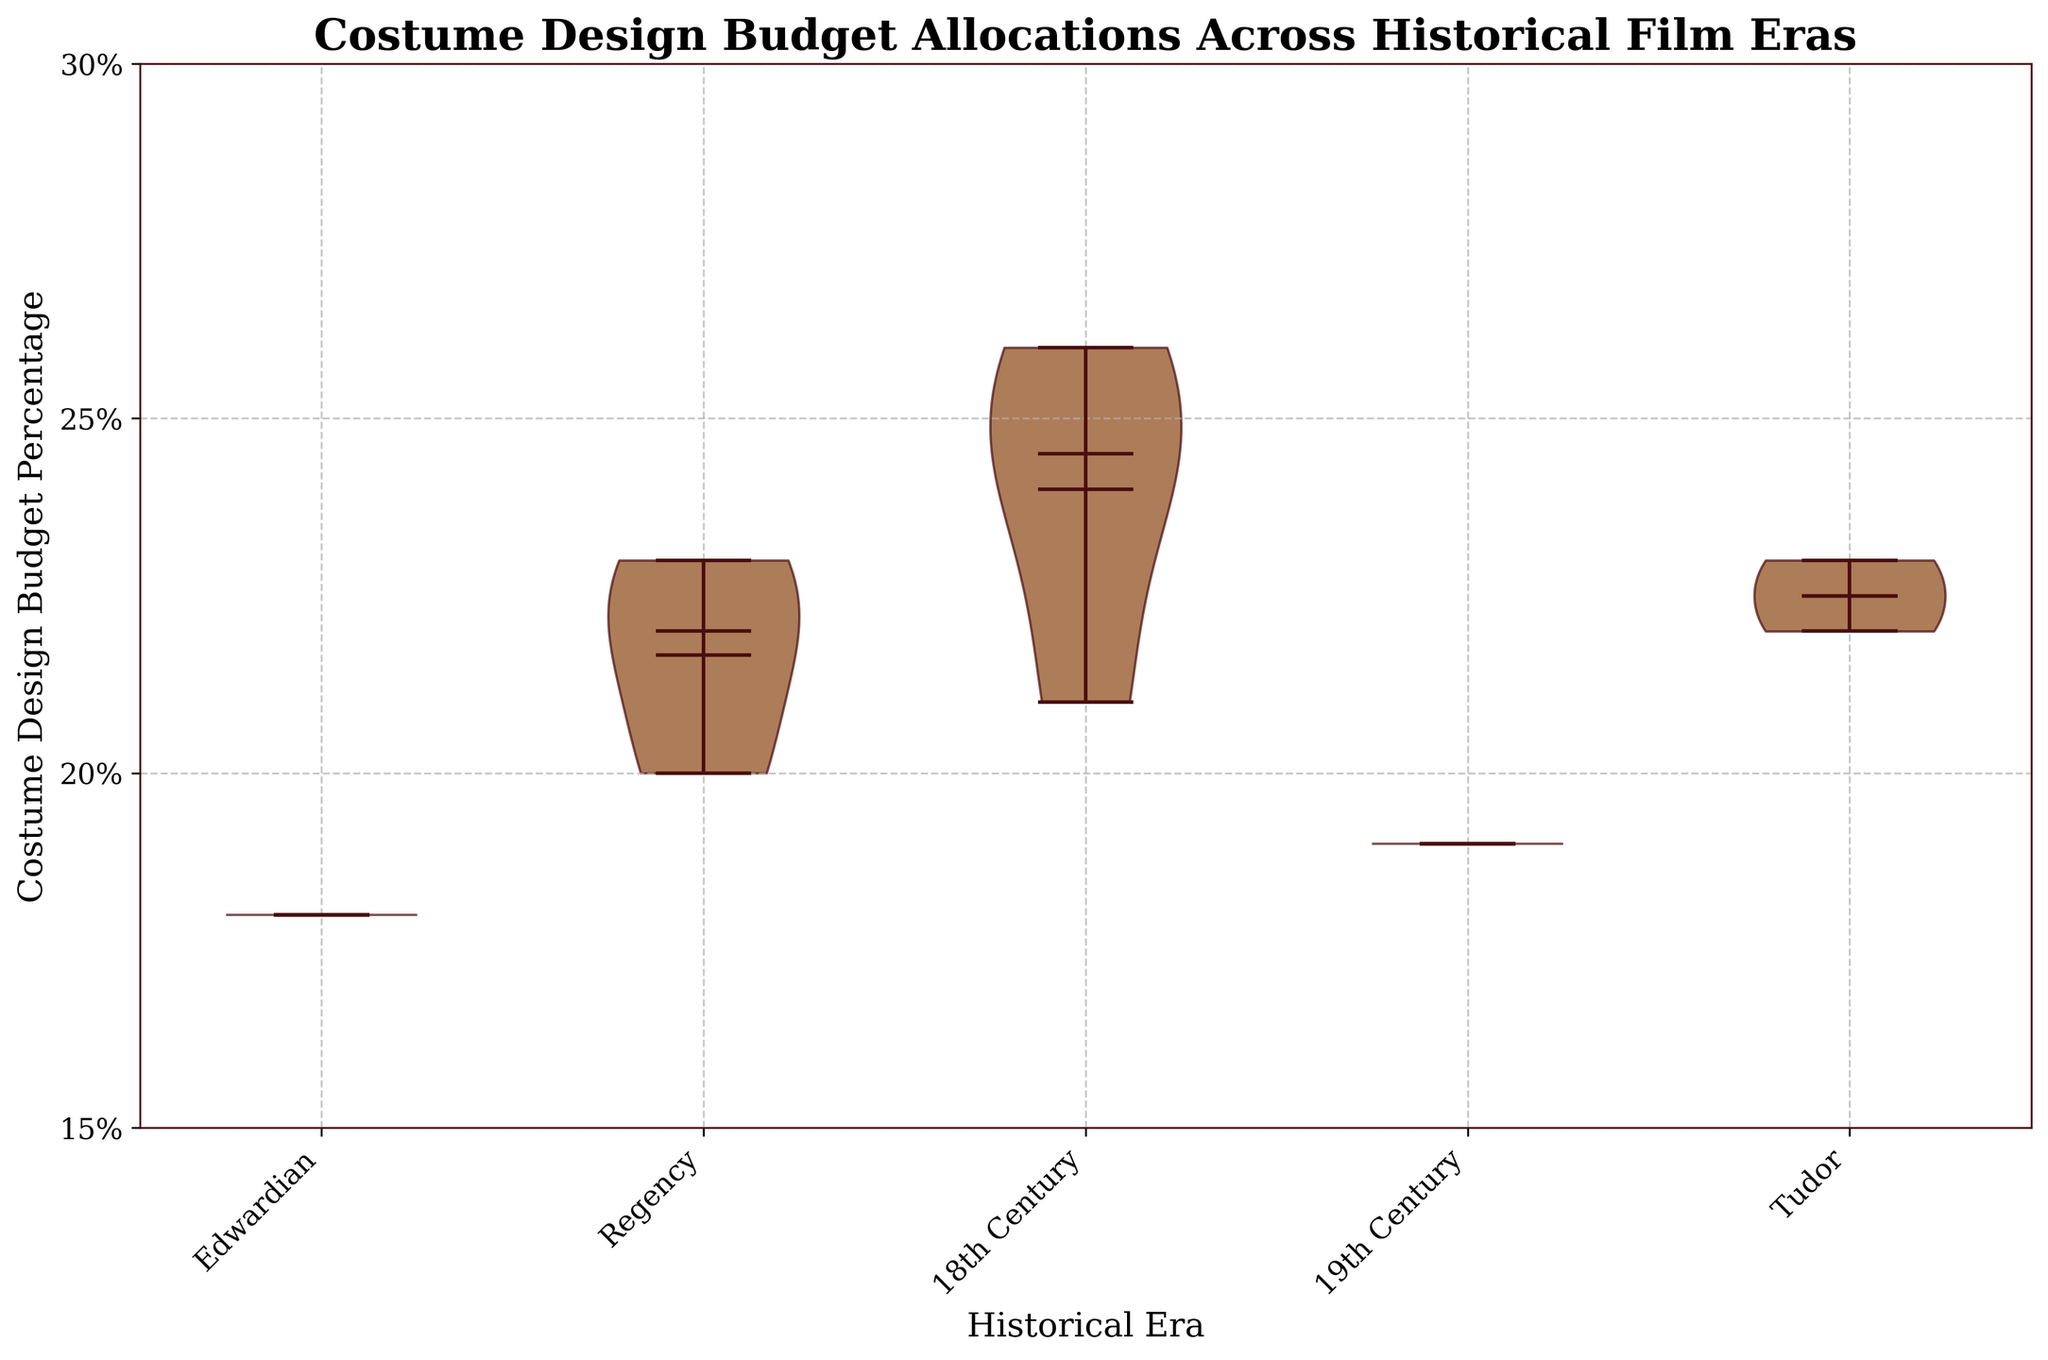What's the title of the chart? The title of the chart is typically located at the top and is the largest text in the figure. It is meant to provide a summary or indicate the main topic of the chart.
Answer: Costume Design Budget Allocations Across Historical Film Eras How many historical eras are compared in the chart? To determine the number of historical eras, look at the x-axis, labeled 'Historical Era,' and count the distinct labels.
Answer: 4 What is the median budget percentage for the 18th Century era? The median is represented by a horizontal line within each violin plot. Find the position of this line for the 18th Century era.
Answer: 24% Which era has the highest average costume design budget percentage? The mean or average value is shown as a dot within each violin plot. Compare the positions of these dots to see which one is the highest.
Answer: 18th Century What is the lowest point of costume design budget percentage in the Edwardian era? The ends of the whiskers of the violin plot indicate the minimum data points for each category. Locate the bottom end of the whisker for the Edwardian era.
Answer: 18% How does the median budget percentage of the 19th Century compare to the Tudor era? Compare the horizontal median lines of the two specified eras. Note if one is higher or lower than the other.
Answer: Lower Which historical era has the smallest range in costume design budget percentages? The range is determined by the distance between the minimum and maximum values in the violin plot for each era. Find the era with the shortest distance between these values.
Answer: Edwardian What is the color of the violin plots? The color of the filled body of the violin plots is visually observed.
Answer: Brown Is the mean budget percentage for the Regency era above or below 21%? Identify the dot representing the mean within the Regency era violin plot and determine its position relative to 21%.
Answer: Above How many budget percentage ticks are labeled on the y-axis? Count the number of distinct labels on the y-axis ranging from the minimum to maximum values.
Answer: 4 